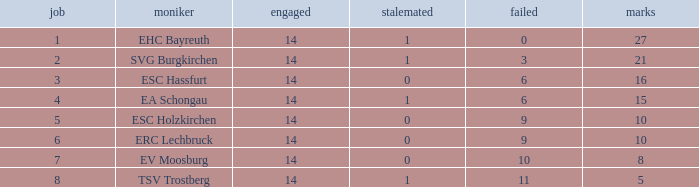What's the points that has a lost more 6, played less than 14 and a position more than 1? None. Parse the table in full. {'header': ['job', 'moniker', 'engaged', 'stalemated', 'failed', 'marks'], 'rows': [['1', 'EHC Bayreuth', '14', '1', '0', '27'], ['2', 'SVG Burgkirchen', '14', '1', '3', '21'], ['3', 'ESC Hassfurt', '14', '0', '6', '16'], ['4', 'EA Schongau', '14', '1', '6', '15'], ['5', 'ESC Holzkirchen', '14', '0', '9', '10'], ['6', 'ERC Lechbruck', '14', '0', '9', '10'], ['7', 'EV Moosburg', '14', '0', '10', '8'], ['8', 'TSV Trostberg', '14', '1', '11', '5']]} 